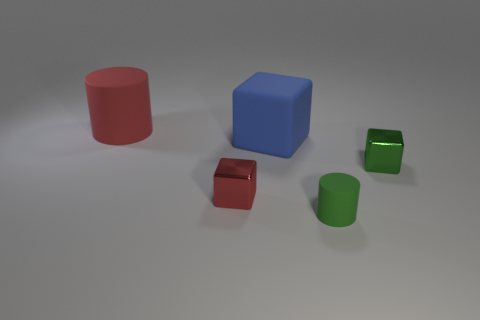What is the object that is in front of the large blue matte cube and behind the tiny red shiny object made of?
Make the answer very short. Metal. Do the tiny matte object and the red object to the left of the small red shiny thing have the same shape?
Keep it short and to the point. Yes. How many other objects are the same size as the green cylinder?
Make the answer very short. 2. Are there more large rubber things than small objects?
Provide a succinct answer. No. How many objects are both left of the blue matte object and in front of the tiny green metal block?
Your answer should be very brief. 1. There is a green thing that is behind the tiny cube in front of the tiny cube that is behind the tiny red object; what is its shape?
Provide a short and direct response. Cube. How many cylinders are green metallic things or blue things?
Provide a short and direct response. 0. There is a large thing that is to the right of the large red matte cylinder; is it the same color as the tiny rubber object?
Your response must be concise. No. There is a cylinder behind the metal block that is in front of the tiny metal object that is on the right side of the big blue block; what is it made of?
Give a very brief answer. Rubber. Do the red rubber cylinder and the green shiny object have the same size?
Offer a terse response. No. 